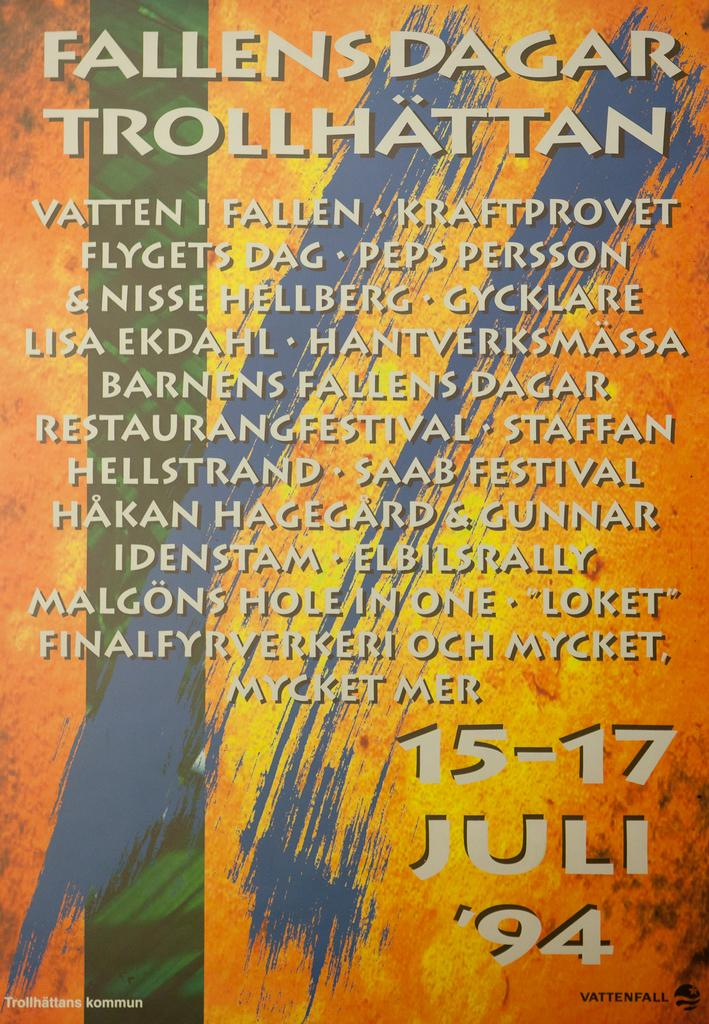<image>
Provide a brief description of the given image. A poster for a 1994 event called Fallens Dagar Trollhattan. 